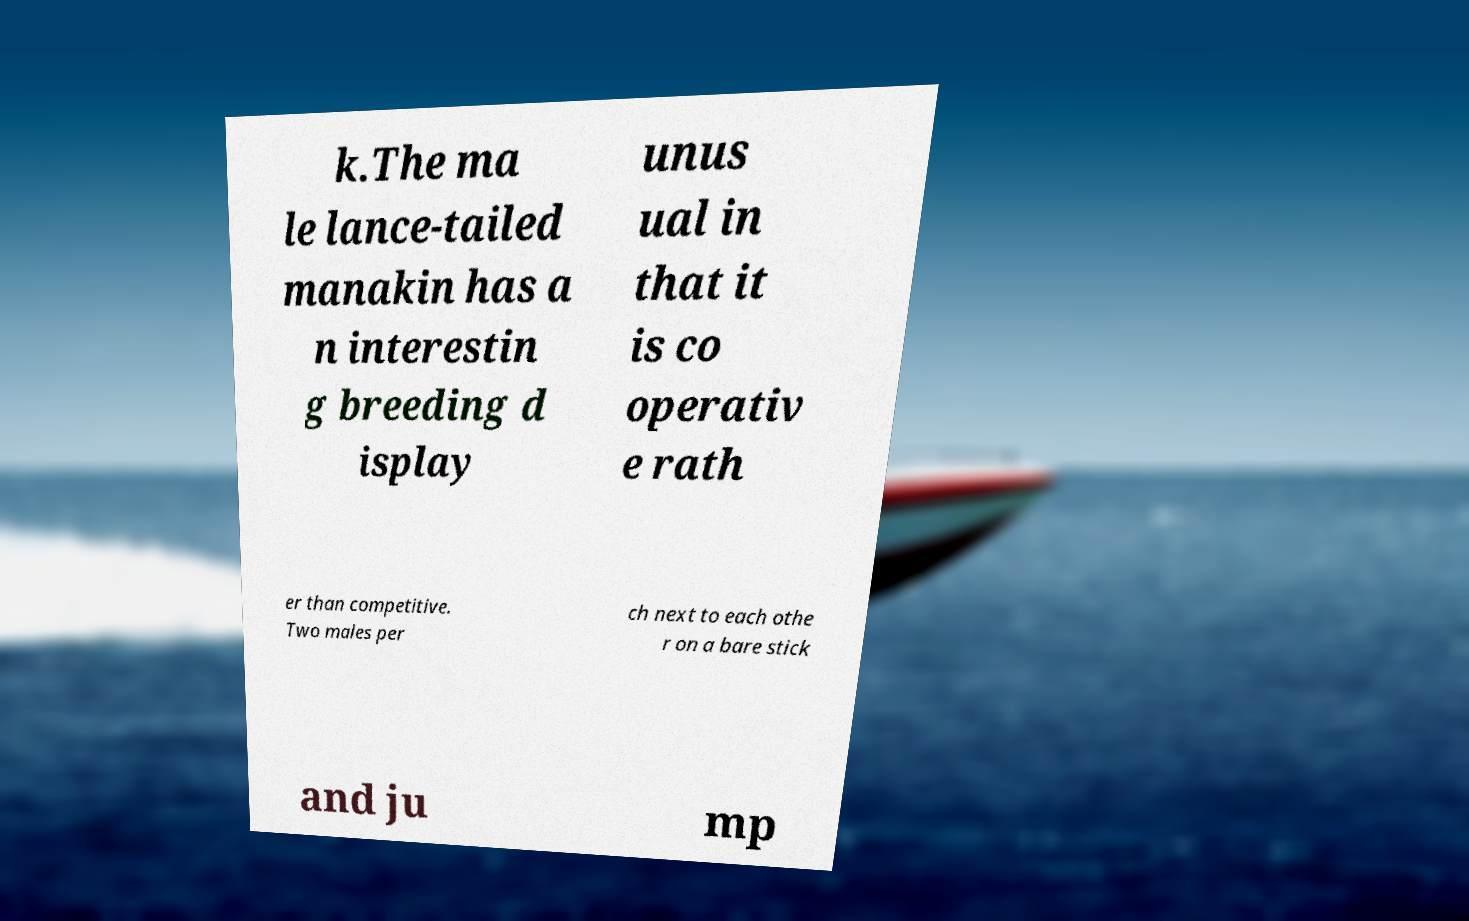Can you accurately transcribe the text from the provided image for me? k.The ma le lance-tailed manakin has a n interestin g breeding d isplay unus ual in that it is co operativ e rath er than competitive. Two males per ch next to each othe r on a bare stick and ju mp 